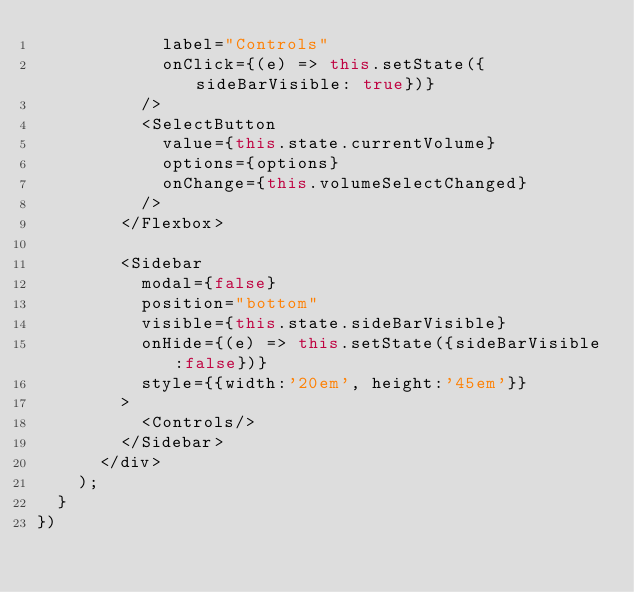<code> <loc_0><loc_0><loc_500><loc_500><_JavaScript_>            label="Controls" 
            onClick={(e) => this.setState({sideBarVisible: true})}
          />
          <SelectButton 
            value={this.state.currentVolume}
            options={options} 
            onChange={this.volumeSelectChanged} 
          /> 
        </Flexbox>

        <Sidebar
          modal={false} 
          position="bottom"
          visible={this.state.sideBarVisible} 
          onHide={(e) => this.setState({sideBarVisible:false})}
          style={{width:'20em', height:'45em'}}
        >
          <Controls/>
        </Sidebar>
      </div>
    );
  }
})</code> 